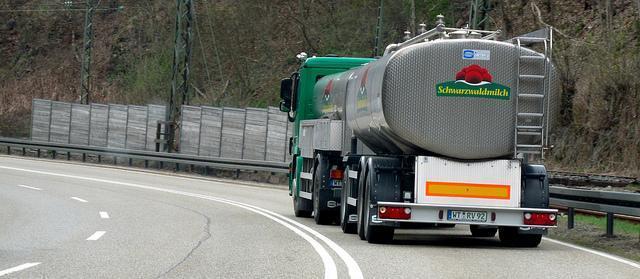How many trucks are in the photo?
Give a very brief answer. 1. 